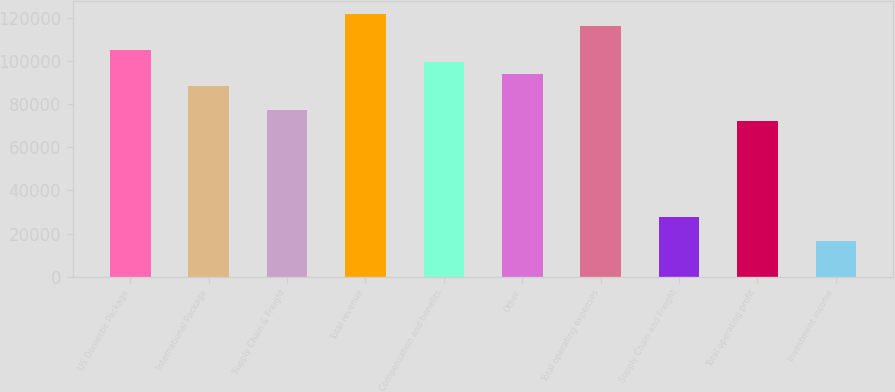<chart> <loc_0><loc_0><loc_500><loc_500><bar_chart><fcel>US Domestic Package<fcel>International Package<fcel>Supply Chain & Freight<fcel>Total revenue<fcel>Compensation and benefits<fcel>Other<fcel>Total operating expenses<fcel>Supply Chain and Freight<fcel>Total operating profit<fcel>Investment income<nl><fcel>105330<fcel>88699.3<fcel>77612.2<fcel>121961<fcel>99786.4<fcel>94242.8<fcel>116417<fcel>27720.2<fcel>72068.6<fcel>16633.1<nl></chart> 